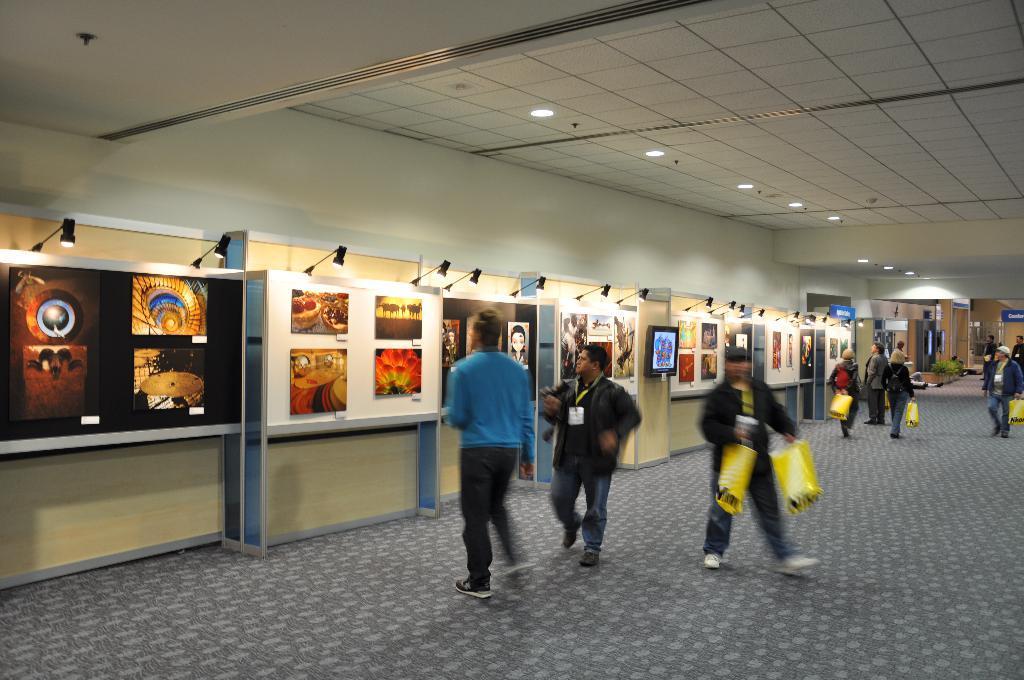Describe this image in one or two sentences. In this picture there are group of people walking. There are pictures on the boards and there are lights on the top of the boards. At the back there are plants. There are group of people holding the covers. At top there are lights. At the bottom there is a mat. 